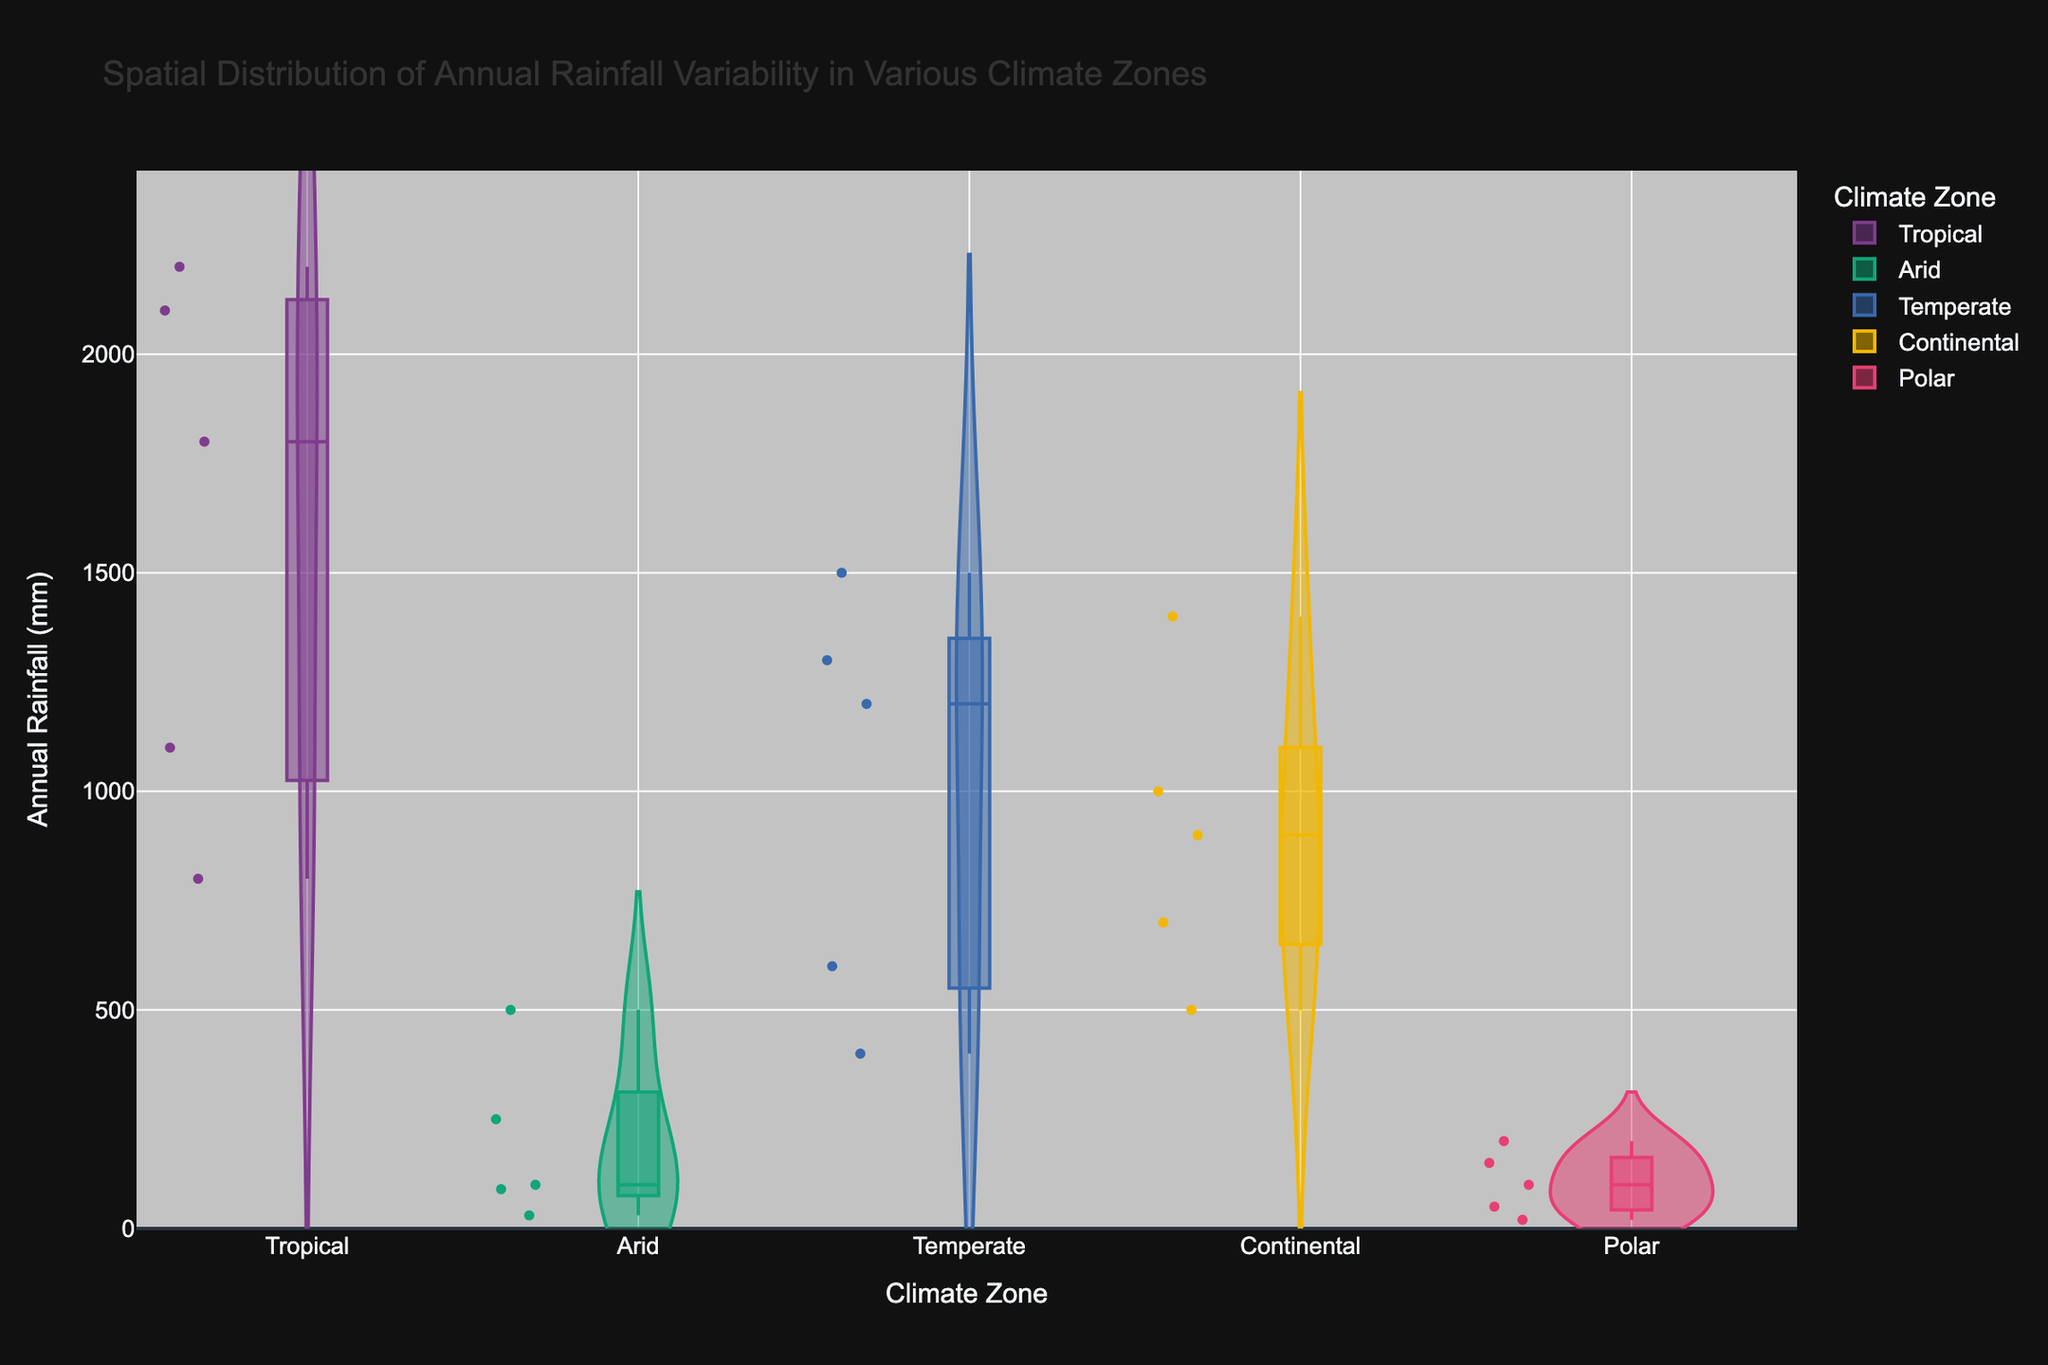What is the title of the figure? The title is displayed at the top of the figure and describes the content of the chart.
Answer: Spatial Distribution of Annual Rainfall Variability in Various Climate Zones Which climate zone has the highest median annual rainfall? By inspecting the box shapes within each violin plot, the tropical climate zone has the highest median line, indicating it has the highest median annual rainfall.
Answer: Tropical How many data points are there in the Arid climate zone? Each dot in the Arid climate zone violin plot represents a data point. Counting the dots gives the number of data points.
Answer: 5 What is the range of annual rainfall for the Polar climate zone? The range can be determined from the whiskers of the box plot within the violin for the Polar zone, spanning from the minimum to the maximum values.
Answer: 20 mm to 200 mm Which location in the Continental climate zone has the highest annual rainfall? By hovering over each data point in the Continental climate zone section, we can see the annual rainfall values and identify the highest one corresponding to Seoul.
Answer: Seoul What is the interquartile range (IQR) of annual rainfall in the Temperate climate zone? The IQR is determined by subtracting the 1st quartile (bottom of the box) from the 3rd quartile (top of the box) in the violin plot for the Temperate zone.
Answer: 400 mm Compare the variability of annual rainfall in the Tropical zone with the Arid zone. The width of the violin plots indicates variability. The Tropical zone has a much wider plot compared to the Arid zone, indicating greater variability in annual rainfall.
Answer: Tropical zone has greater variability What is the median annual rainfall in the Temperate climate zone? The median is indicated by the central line within the box plot inside the violin. For the Temperate zone, it is around 1200 mm.
Answer: 1200 mm Rank the climate zones by their median annual rainfall from highest to lowest. By comparing the median lines across all the violin plots, we can rank the zones as follows: Tropical, Temperate, Continental, Arid, Polar.
Answer: Tropical > Temperate > Continental > Arid > Polar 